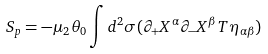Convert formula to latex. <formula><loc_0><loc_0><loc_500><loc_500>S _ { p } = - \mu _ { 2 } \theta _ { 0 } \int d ^ { 2 } \sigma ( \partial _ { + } X ^ { \alpha } \partial _ { - } X ^ { \beta } T \eta _ { \alpha \beta } )</formula> 